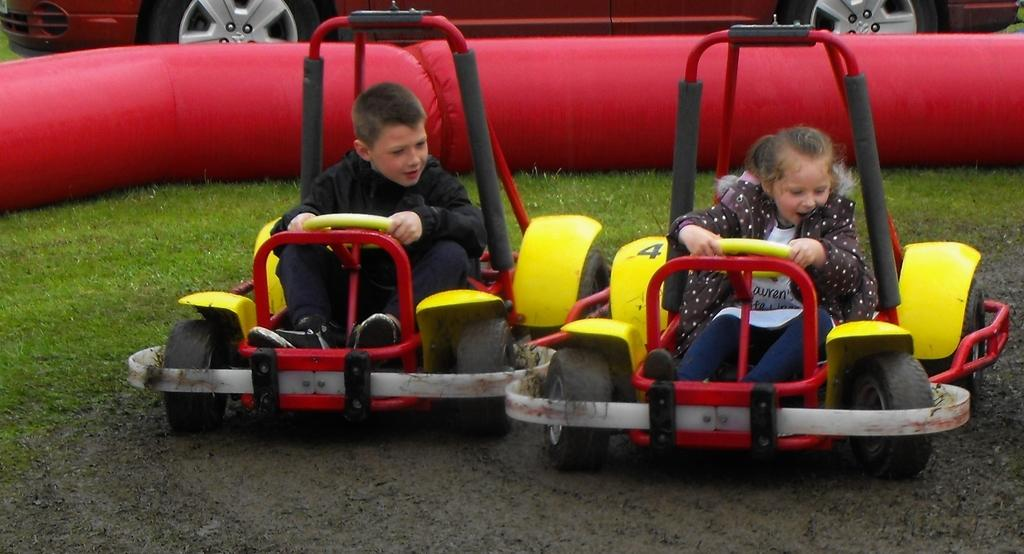Who is present in the image? There is a boy and a girl in the image. What are the boy and the girl doing in the image? Both the boy and the girl are riding a go-kart. What can be seen in the background of the image? There are red balloons and a car in the background of the image. What are the boy and the girl wearing? The boy and the girl are wearing jackets. What type of secretary can be seen working in the image? There is no secretary present in the image; it features a boy and a girl riding a go-kart. Can you describe the ocean visible in the image? There is no ocean present in the image; it features a boy and a girl riding a go-kart with a background of red balloons and a car. 